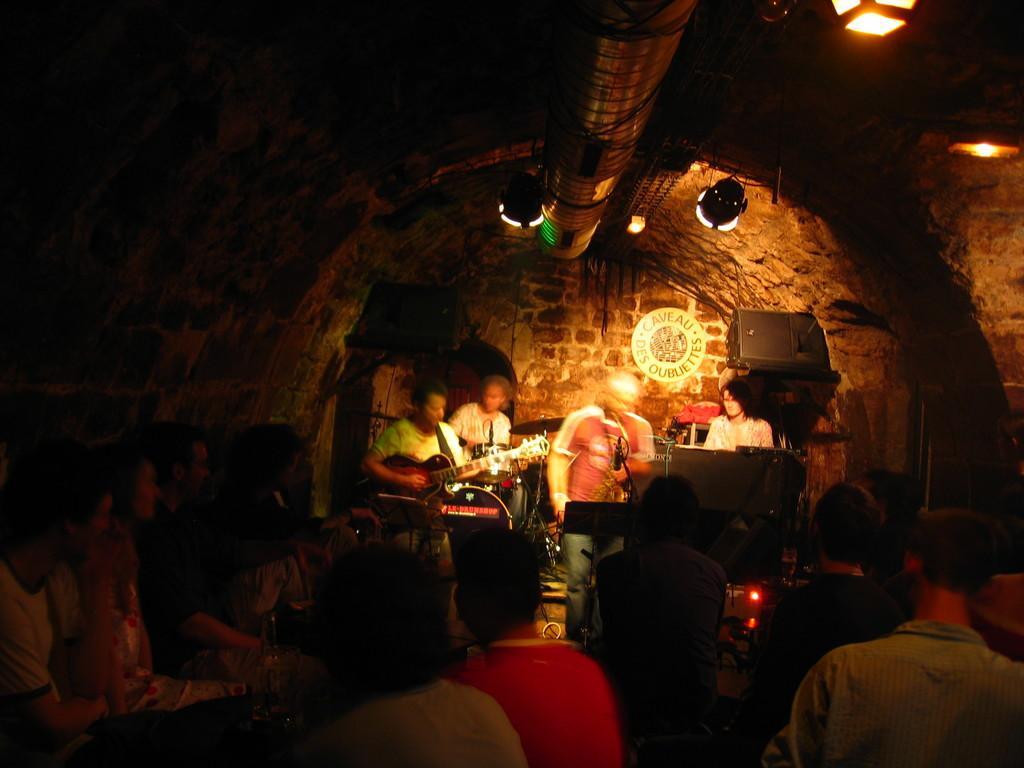Describe this image in one or two sentences. In the foreground of the image, there are group of people sitting at the bottom and few are sitting on the chair and playing musical instruments. And one person is standing and singing a song. A top is like a cave and a duct is there and lights are fixed to it. In the background board is visible and speakers are visible. This image is taken inside a cave during night time. 